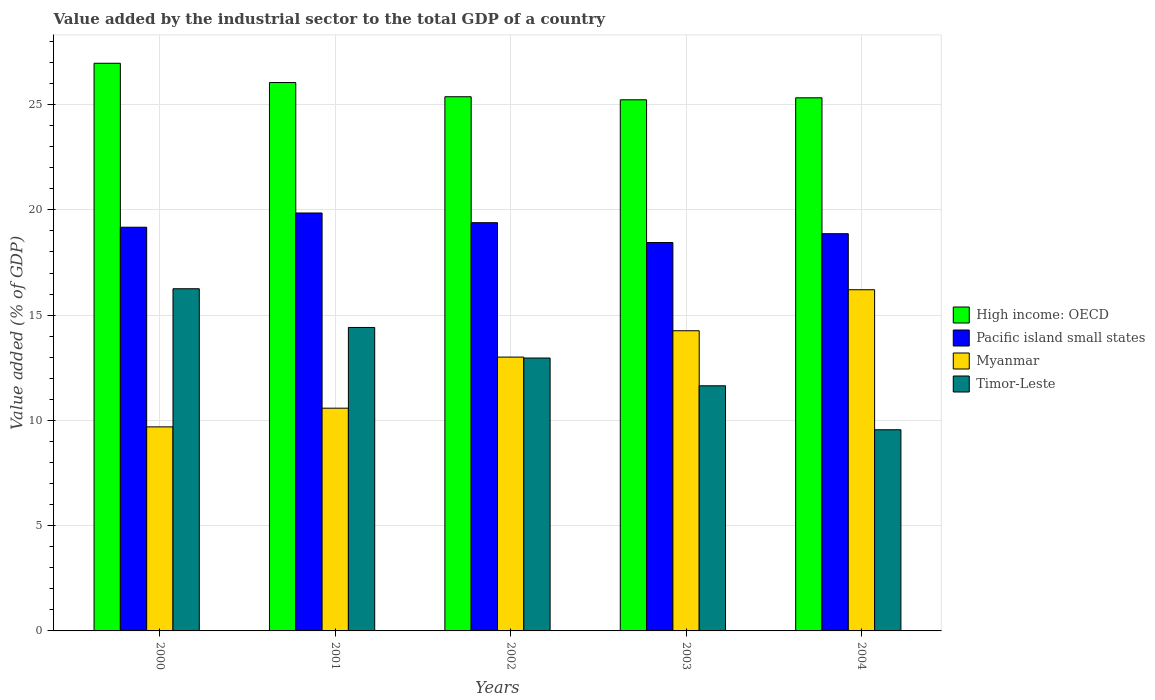How many different coloured bars are there?
Keep it short and to the point. 4. Are the number of bars on each tick of the X-axis equal?
Your answer should be compact. Yes. How many bars are there on the 5th tick from the left?
Offer a terse response. 4. In how many cases, is the number of bars for a given year not equal to the number of legend labels?
Offer a terse response. 0. What is the value added by the industrial sector to the total GDP in High income: OECD in 2004?
Make the answer very short. 25.32. Across all years, what is the maximum value added by the industrial sector to the total GDP in High income: OECD?
Give a very brief answer. 26.96. Across all years, what is the minimum value added by the industrial sector to the total GDP in Pacific island small states?
Your answer should be very brief. 18.45. In which year was the value added by the industrial sector to the total GDP in Timor-Leste minimum?
Provide a short and direct response. 2004. What is the total value added by the industrial sector to the total GDP in Pacific island small states in the graph?
Keep it short and to the point. 95.73. What is the difference between the value added by the industrial sector to the total GDP in Myanmar in 2001 and that in 2004?
Ensure brevity in your answer.  -5.63. What is the difference between the value added by the industrial sector to the total GDP in Timor-Leste in 2000 and the value added by the industrial sector to the total GDP in High income: OECD in 2001?
Your answer should be compact. -9.79. What is the average value added by the industrial sector to the total GDP in Pacific island small states per year?
Your answer should be very brief. 19.15. In the year 2000, what is the difference between the value added by the industrial sector to the total GDP in Pacific island small states and value added by the industrial sector to the total GDP in Timor-Leste?
Keep it short and to the point. 2.92. In how many years, is the value added by the industrial sector to the total GDP in Myanmar greater than 6 %?
Provide a succinct answer. 5. What is the ratio of the value added by the industrial sector to the total GDP in High income: OECD in 2000 to that in 2002?
Provide a succinct answer. 1.06. Is the value added by the industrial sector to the total GDP in High income: OECD in 2001 less than that in 2002?
Your response must be concise. No. Is the difference between the value added by the industrial sector to the total GDP in Pacific island small states in 2001 and 2003 greater than the difference between the value added by the industrial sector to the total GDP in Timor-Leste in 2001 and 2003?
Your response must be concise. No. What is the difference between the highest and the second highest value added by the industrial sector to the total GDP in Myanmar?
Your answer should be compact. 1.95. What is the difference between the highest and the lowest value added by the industrial sector to the total GDP in Myanmar?
Provide a succinct answer. 6.51. In how many years, is the value added by the industrial sector to the total GDP in High income: OECD greater than the average value added by the industrial sector to the total GDP in High income: OECD taken over all years?
Provide a succinct answer. 2. Is it the case that in every year, the sum of the value added by the industrial sector to the total GDP in Myanmar and value added by the industrial sector to the total GDP in Pacific island small states is greater than the sum of value added by the industrial sector to the total GDP in Timor-Leste and value added by the industrial sector to the total GDP in High income: OECD?
Your answer should be very brief. Yes. What does the 1st bar from the left in 2002 represents?
Offer a very short reply. High income: OECD. What does the 3rd bar from the right in 2004 represents?
Offer a very short reply. Pacific island small states. Is it the case that in every year, the sum of the value added by the industrial sector to the total GDP in Pacific island small states and value added by the industrial sector to the total GDP in High income: OECD is greater than the value added by the industrial sector to the total GDP in Timor-Leste?
Provide a short and direct response. Yes. How many bars are there?
Your response must be concise. 20. What is the difference between two consecutive major ticks on the Y-axis?
Ensure brevity in your answer.  5. Where does the legend appear in the graph?
Ensure brevity in your answer.  Center right. How are the legend labels stacked?
Your response must be concise. Vertical. What is the title of the graph?
Provide a short and direct response. Value added by the industrial sector to the total GDP of a country. What is the label or title of the Y-axis?
Your response must be concise. Value added (% of GDP). What is the Value added (% of GDP) of High income: OECD in 2000?
Your response must be concise. 26.96. What is the Value added (% of GDP) in Pacific island small states in 2000?
Your answer should be very brief. 19.18. What is the Value added (% of GDP) of Myanmar in 2000?
Your response must be concise. 9.69. What is the Value added (% of GDP) in Timor-Leste in 2000?
Give a very brief answer. 16.25. What is the Value added (% of GDP) in High income: OECD in 2001?
Give a very brief answer. 26.05. What is the Value added (% of GDP) of Pacific island small states in 2001?
Make the answer very short. 19.85. What is the Value added (% of GDP) of Myanmar in 2001?
Keep it short and to the point. 10.58. What is the Value added (% of GDP) of Timor-Leste in 2001?
Your response must be concise. 14.41. What is the Value added (% of GDP) in High income: OECD in 2002?
Make the answer very short. 25.37. What is the Value added (% of GDP) of Pacific island small states in 2002?
Offer a terse response. 19.39. What is the Value added (% of GDP) in Myanmar in 2002?
Offer a terse response. 13.01. What is the Value added (% of GDP) in Timor-Leste in 2002?
Keep it short and to the point. 12.96. What is the Value added (% of GDP) in High income: OECD in 2003?
Keep it short and to the point. 25.23. What is the Value added (% of GDP) of Pacific island small states in 2003?
Offer a very short reply. 18.45. What is the Value added (% of GDP) of Myanmar in 2003?
Keep it short and to the point. 14.26. What is the Value added (% of GDP) in Timor-Leste in 2003?
Your answer should be compact. 11.64. What is the Value added (% of GDP) in High income: OECD in 2004?
Your answer should be very brief. 25.32. What is the Value added (% of GDP) of Pacific island small states in 2004?
Your answer should be very brief. 18.87. What is the Value added (% of GDP) of Myanmar in 2004?
Make the answer very short. 16.21. What is the Value added (% of GDP) of Timor-Leste in 2004?
Make the answer very short. 9.56. Across all years, what is the maximum Value added (% of GDP) in High income: OECD?
Provide a short and direct response. 26.96. Across all years, what is the maximum Value added (% of GDP) in Pacific island small states?
Your answer should be very brief. 19.85. Across all years, what is the maximum Value added (% of GDP) of Myanmar?
Your answer should be very brief. 16.21. Across all years, what is the maximum Value added (% of GDP) of Timor-Leste?
Provide a short and direct response. 16.25. Across all years, what is the minimum Value added (% of GDP) of High income: OECD?
Your answer should be very brief. 25.23. Across all years, what is the minimum Value added (% of GDP) of Pacific island small states?
Make the answer very short. 18.45. Across all years, what is the minimum Value added (% of GDP) in Myanmar?
Give a very brief answer. 9.69. Across all years, what is the minimum Value added (% of GDP) in Timor-Leste?
Keep it short and to the point. 9.56. What is the total Value added (% of GDP) of High income: OECD in the graph?
Your response must be concise. 128.94. What is the total Value added (% of GDP) in Pacific island small states in the graph?
Keep it short and to the point. 95.73. What is the total Value added (% of GDP) of Myanmar in the graph?
Your answer should be compact. 63.74. What is the total Value added (% of GDP) in Timor-Leste in the graph?
Keep it short and to the point. 64.83. What is the difference between the Value added (% of GDP) in High income: OECD in 2000 and that in 2001?
Your response must be concise. 0.92. What is the difference between the Value added (% of GDP) in Pacific island small states in 2000 and that in 2001?
Offer a very short reply. -0.68. What is the difference between the Value added (% of GDP) of Myanmar in 2000 and that in 2001?
Provide a succinct answer. -0.89. What is the difference between the Value added (% of GDP) of Timor-Leste in 2000 and that in 2001?
Make the answer very short. 1.84. What is the difference between the Value added (% of GDP) in High income: OECD in 2000 and that in 2002?
Your answer should be compact. 1.59. What is the difference between the Value added (% of GDP) of Pacific island small states in 2000 and that in 2002?
Make the answer very short. -0.22. What is the difference between the Value added (% of GDP) in Myanmar in 2000 and that in 2002?
Provide a succinct answer. -3.31. What is the difference between the Value added (% of GDP) of Timor-Leste in 2000 and that in 2002?
Provide a short and direct response. 3.29. What is the difference between the Value added (% of GDP) in High income: OECD in 2000 and that in 2003?
Offer a terse response. 1.73. What is the difference between the Value added (% of GDP) of Pacific island small states in 2000 and that in 2003?
Ensure brevity in your answer.  0.73. What is the difference between the Value added (% of GDP) in Myanmar in 2000 and that in 2003?
Your response must be concise. -4.57. What is the difference between the Value added (% of GDP) of Timor-Leste in 2000 and that in 2003?
Your answer should be very brief. 4.61. What is the difference between the Value added (% of GDP) in High income: OECD in 2000 and that in 2004?
Ensure brevity in your answer.  1.64. What is the difference between the Value added (% of GDP) of Pacific island small states in 2000 and that in 2004?
Offer a terse response. 0.31. What is the difference between the Value added (% of GDP) in Myanmar in 2000 and that in 2004?
Offer a very short reply. -6.51. What is the difference between the Value added (% of GDP) of Timor-Leste in 2000 and that in 2004?
Your answer should be very brief. 6.7. What is the difference between the Value added (% of GDP) of High income: OECD in 2001 and that in 2002?
Your answer should be very brief. 0.67. What is the difference between the Value added (% of GDP) of Pacific island small states in 2001 and that in 2002?
Your answer should be compact. 0.46. What is the difference between the Value added (% of GDP) in Myanmar in 2001 and that in 2002?
Offer a terse response. -2.43. What is the difference between the Value added (% of GDP) in Timor-Leste in 2001 and that in 2002?
Provide a short and direct response. 1.45. What is the difference between the Value added (% of GDP) of High income: OECD in 2001 and that in 2003?
Keep it short and to the point. 0.82. What is the difference between the Value added (% of GDP) of Pacific island small states in 2001 and that in 2003?
Offer a terse response. 1.4. What is the difference between the Value added (% of GDP) of Myanmar in 2001 and that in 2003?
Ensure brevity in your answer.  -3.68. What is the difference between the Value added (% of GDP) of Timor-Leste in 2001 and that in 2003?
Give a very brief answer. 2.77. What is the difference between the Value added (% of GDP) of High income: OECD in 2001 and that in 2004?
Provide a succinct answer. 0.73. What is the difference between the Value added (% of GDP) of Pacific island small states in 2001 and that in 2004?
Your response must be concise. 0.98. What is the difference between the Value added (% of GDP) of Myanmar in 2001 and that in 2004?
Provide a short and direct response. -5.63. What is the difference between the Value added (% of GDP) of Timor-Leste in 2001 and that in 2004?
Keep it short and to the point. 4.86. What is the difference between the Value added (% of GDP) in High income: OECD in 2002 and that in 2003?
Give a very brief answer. 0.14. What is the difference between the Value added (% of GDP) in Pacific island small states in 2002 and that in 2003?
Offer a terse response. 0.94. What is the difference between the Value added (% of GDP) of Myanmar in 2002 and that in 2003?
Keep it short and to the point. -1.25. What is the difference between the Value added (% of GDP) in Timor-Leste in 2002 and that in 2003?
Offer a very short reply. 1.32. What is the difference between the Value added (% of GDP) in High income: OECD in 2002 and that in 2004?
Your response must be concise. 0.05. What is the difference between the Value added (% of GDP) of Pacific island small states in 2002 and that in 2004?
Ensure brevity in your answer.  0.52. What is the difference between the Value added (% of GDP) of Myanmar in 2002 and that in 2004?
Offer a terse response. -3.2. What is the difference between the Value added (% of GDP) of Timor-Leste in 2002 and that in 2004?
Keep it short and to the point. 3.41. What is the difference between the Value added (% of GDP) in High income: OECD in 2003 and that in 2004?
Ensure brevity in your answer.  -0.09. What is the difference between the Value added (% of GDP) of Pacific island small states in 2003 and that in 2004?
Your response must be concise. -0.42. What is the difference between the Value added (% of GDP) in Myanmar in 2003 and that in 2004?
Ensure brevity in your answer.  -1.95. What is the difference between the Value added (% of GDP) of Timor-Leste in 2003 and that in 2004?
Ensure brevity in your answer.  2.09. What is the difference between the Value added (% of GDP) in High income: OECD in 2000 and the Value added (% of GDP) in Pacific island small states in 2001?
Your answer should be compact. 7.11. What is the difference between the Value added (% of GDP) in High income: OECD in 2000 and the Value added (% of GDP) in Myanmar in 2001?
Offer a very short reply. 16.38. What is the difference between the Value added (% of GDP) of High income: OECD in 2000 and the Value added (% of GDP) of Timor-Leste in 2001?
Give a very brief answer. 12.55. What is the difference between the Value added (% of GDP) of Pacific island small states in 2000 and the Value added (% of GDP) of Myanmar in 2001?
Make the answer very short. 8.6. What is the difference between the Value added (% of GDP) of Pacific island small states in 2000 and the Value added (% of GDP) of Timor-Leste in 2001?
Give a very brief answer. 4.76. What is the difference between the Value added (% of GDP) of Myanmar in 2000 and the Value added (% of GDP) of Timor-Leste in 2001?
Offer a terse response. -4.72. What is the difference between the Value added (% of GDP) in High income: OECD in 2000 and the Value added (% of GDP) in Pacific island small states in 2002?
Provide a short and direct response. 7.57. What is the difference between the Value added (% of GDP) in High income: OECD in 2000 and the Value added (% of GDP) in Myanmar in 2002?
Provide a short and direct response. 13.96. What is the difference between the Value added (% of GDP) in High income: OECD in 2000 and the Value added (% of GDP) in Timor-Leste in 2002?
Ensure brevity in your answer.  14. What is the difference between the Value added (% of GDP) in Pacific island small states in 2000 and the Value added (% of GDP) in Myanmar in 2002?
Make the answer very short. 6.17. What is the difference between the Value added (% of GDP) in Pacific island small states in 2000 and the Value added (% of GDP) in Timor-Leste in 2002?
Make the answer very short. 6.21. What is the difference between the Value added (% of GDP) in Myanmar in 2000 and the Value added (% of GDP) in Timor-Leste in 2002?
Keep it short and to the point. -3.27. What is the difference between the Value added (% of GDP) of High income: OECD in 2000 and the Value added (% of GDP) of Pacific island small states in 2003?
Your answer should be compact. 8.52. What is the difference between the Value added (% of GDP) of High income: OECD in 2000 and the Value added (% of GDP) of Myanmar in 2003?
Ensure brevity in your answer.  12.71. What is the difference between the Value added (% of GDP) of High income: OECD in 2000 and the Value added (% of GDP) of Timor-Leste in 2003?
Provide a succinct answer. 15.32. What is the difference between the Value added (% of GDP) in Pacific island small states in 2000 and the Value added (% of GDP) in Myanmar in 2003?
Make the answer very short. 4.92. What is the difference between the Value added (% of GDP) of Pacific island small states in 2000 and the Value added (% of GDP) of Timor-Leste in 2003?
Make the answer very short. 7.53. What is the difference between the Value added (% of GDP) of Myanmar in 2000 and the Value added (% of GDP) of Timor-Leste in 2003?
Your answer should be compact. -1.95. What is the difference between the Value added (% of GDP) in High income: OECD in 2000 and the Value added (% of GDP) in Pacific island small states in 2004?
Make the answer very short. 8.1. What is the difference between the Value added (% of GDP) in High income: OECD in 2000 and the Value added (% of GDP) in Myanmar in 2004?
Give a very brief answer. 10.76. What is the difference between the Value added (% of GDP) in High income: OECD in 2000 and the Value added (% of GDP) in Timor-Leste in 2004?
Offer a very short reply. 17.41. What is the difference between the Value added (% of GDP) in Pacific island small states in 2000 and the Value added (% of GDP) in Myanmar in 2004?
Give a very brief answer. 2.97. What is the difference between the Value added (% of GDP) in Pacific island small states in 2000 and the Value added (% of GDP) in Timor-Leste in 2004?
Your answer should be very brief. 9.62. What is the difference between the Value added (% of GDP) of Myanmar in 2000 and the Value added (% of GDP) of Timor-Leste in 2004?
Your answer should be very brief. 0.14. What is the difference between the Value added (% of GDP) of High income: OECD in 2001 and the Value added (% of GDP) of Pacific island small states in 2002?
Your answer should be compact. 6.66. What is the difference between the Value added (% of GDP) of High income: OECD in 2001 and the Value added (% of GDP) of Myanmar in 2002?
Your response must be concise. 13.04. What is the difference between the Value added (% of GDP) of High income: OECD in 2001 and the Value added (% of GDP) of Timor-Leste in 2002?
Provide a short and direct response. 13.09. What is the difference between the Value added (% of GDP) of Pacific island small states in 2001 and the Value added (% of GDP) of Myanmar in 2002?
Your answer should be very brief. 6.84. What is the difference between the Value added (% of GDP) in Pacific island small states in 2001 and the Value added (% of GDP) in Timor-Leste in 2002?
Provide a succinct answer. 6.89. What is the difference between the Value added (% of GDP) of Myanmar in 2001 and the Value added (% of GDP) of Timor-Leste in 2002?
Make the answer very short. -2.38. What is the difference between the Value added (% of GDP) of High income: OECD in 2001 and the Value added (% of GDP) of Pacific island small states in 2003?
Keep it short and to the point. 7.6. What is the difference between the Value added (% of GDP) in High income: OECD in 2001 and the Value added (% of GDP) in Myanmar in 2003?
Offer a terse response. 11.79. What is the difference between the Value added (% of GDP) of High income: OECD in 2001 and the Value added (% of GDP) of Timor-Leste in 2003?
Provide a short and direct response. 14.4. What is the difference between the Value added (% of GDP) in Pacific island small states in 2001 and the Value added (% of GDP) in Myanmar in 2003?
Make the answer very short. 5.59. What is the difference between the Value added (% of GDP) of Pacific island small states in 2001 and the Value added (% of GDP) of Timor-Leste in 2003?
Give a very brief answer. 8.21. What is the difference between the Value added (% of GDP) of Myanmar in 2001 and the Value added (% of GDP) of Timor-Leste in 2003?
Ensure brevity in your answer.  -1.06. What is the difference between the Value added (% of GDP) of High income: OECD in 2001 and the Value added (% of GDP) of Pacific island small states in 2004?
Keep it short and to the point. 7.18. What is the difference between the Value added (% of GDP) of High income: OECD in 2001 and the Value added (% of GDP) of Myanmar in 2004?
Provide a short and direct response. 9.84. What is the difference between the Value added (% of GDP) in High income: OECD in 2001 and the Value added (% of GDP) in Timor-Leste in 2004?
Make the answer very short. 16.49. What is the difference between the Value added (% of GDP) in Pacific island small states in 2001 and the Value added (% of GDP) in Myanmar in 2004?
Offer a terse response. 3.65. What is the difference between the Value added (% of GDP) in Pacific island small states in 2001 and the Value added (% of GDP) in Timor-Leste in 2004?
Your answer should be very brief. 10.3. What is the difference between the Value added (% of GDP) in Myanmar in 2001 and the Value added (% of GDP) in Timor-Leste in 2004?
Provide a succinct answer. 1.02. What is the difference between the Value added (% of GDP) in High income: OECD in 2002 and the Value added (% of GDP) in Pacific island small states in 2003?
Make the answer very short. 6.93. What is the difference between the Value added (% of GDP) of High income: OECD in 2002 and the Value added (% of GDP) of Myanmar in 2003?
Make the answer very short. 11.12. What is the difference between the Value added (% of GDP) in High income: OECD in 2002 and the Value added (% of GDP) in Timor-Leste in 2003?
Provide a short and direct response. 13.73. What is the difference between the Value added (% of GDP) of Pacific island small states in 2002 and the Value added (% of GDP) of Myanmar in 2003?
Ensure brevity in your answer.  5.13. What is the difference between the Value added (% of GDP) of Pacific island small states in 2002 and the Value added (% of GDP) of Timor-Leste in 2003?
Your response must be concise. 7.75. What is the difference between the Value added (% of GDP) in Myanmar in 2002 and the Value added (% of GDP) in Timor-Leste in 2003?
Your answer should be compact. 1.36. What is the difference between the Value added (% of GDP) in High income: OECD in 2002 and the Value added (% of GDP) in Pacific island small states in 2004?
Give a very brief answer. 6.51. What is the difference between the Value added (% of GDP) of High income: OECD in 2002 and the Value added (% of GDP) of Myanmar in 2004?
Your answer should be very brief. 9.17. What is the difference between the Value added (% of GDP) of High income: OECD in 2002 and the Value added (% of GDP) of Timor-Leste in 2004?
Ensure brevity in your answer.  15.82. What is the difference between the Value added (% of GDP) in Pacific island small states in 2002 and the Value added (% of GDP) in Myanmar in 2004?
Offer a terse response. 3.19. What is the difference between the Value added (% of GDP) of Pacific island small states in 2002 and the Value added (% of GDP) of Timor-Leste in 2004?
Make the answer very short. 9.84. What is the difference between the Value added (% of GDP) of Myanmar in 2002 and the Value added (% of GDP) of Timor-Leste in 2004?
Your answer should be compact. 3.45. What is the difference between the Value added (% of GDP) in High income: OECD in 2003 and the Value added (% of GDP) in Pacific island small states in 2004?
Make the answer very short. 6.36. What is the difference between the Value added (% of GDP) in High income: OECD in 2003 and the Value added (% of GDP) in Myanmar in 2004?
Your answer should be very brief. 9.02. What is the difference between the Value added (% of GDP) of High income: OECD in 2003 and the Value added (% of GDP) of Timor-Leste in 2004?
Your answer should be compact. 15.67. What is the difference between the Value added (% of GDP) in Pacific island small states in 2003 and the Value added (% of GDP) in Myanmar in 2004?
Provide a short and direct response. 2.24. What is the difference between the Value added (% of GDP) of Pacific island small states in 2003 and the Value added (% of GDP) of Timor-Leste in 2004?
Your response must be concise. 8.89. What is the difference between the Value added (% of GDP) of Myanmar in 2003 and the Value added (% of GDP) of Timor-Leste in 2004?
Make the answer very short. 4.7. What is the average Value added (% of GDP) of High income: OECD per year?
Offer a terse response. 25.79. What is the average Value added (% of GDP) of Pacific island small states per year?
Your response must be concise. 19.15. What is the average Value added (% of GDP) in Myanmar per year?
Give a very brief answer. 12.75. What is the average Value added (% of GDP) in Timor-Leste per year?
Keep it short and to the point. 12.97. In the year 2000, what is the difference between the Value added (% of GDP) of High income: OECD and Value added (% of GDP) of Pacific island small states?
Make the answer very short. 7.79. In the year 2000, what is the difference between the Value added (% of GDP) of High income: OECD and Value added (% of GDP) of Myanmar?
Ensure brevity in your answer.  17.27. In the year 2000, what is the difference between the Value added (% of GDP) of High income: OECD and Value added (% of GDP) of Timor-Leste?
Keep it short and to the point. 10.71. In the year 2000, what is the difference between the Value added (% of GDP) of Pacific island small states and Value added (% of GDP) of Myanmar?
Your answer should be very brief. 9.48. In the year 2000, what is the difference between the Value added (% of GDP) in Pacific island small states and Value added (% of GDP) in Timor-Leste?
Give a very brief answer. 2.92. In the year 2000, what is the difference between the Value added (% of GDP) of Myanmar and Value added (% of GDP) of Timor-Leste?
Offer a very short reply. -6.56. In the year 2001, what is the difference between the Value added (% of GDP) in High income: OECD and Value added (% of GDP) in Pacific island small states?
Your response must be concise. 6.2. In the year 2001, what is the difference between the Value added (% of GDP) in High income: OECD and Value added (% of GDP) in Myanmar?
Make the answer very short. 15.47. In the year 2001, what is the difference between the Value added (% of GDP) in High income: OECD and Value added (% of GDP) in Timor-Leste?
Provide a short and direct response. 11.63. In the year 2001, what is the difference between the Value added (% of GDP) of Pacific island small states and Value added (% of GDP) of Myanmar?
Your answer should be compact. 9.27. In the year 2001, what is the difference between the Value added (% of GDP) of Pacific island small states and Value added (% of GDP) of Timor-Leste?
Make the answer very short. 5.44. In the year 2001, what is the difference between the Value added (% of GDP) in Myanmar and Value added (% of GDP) in Timor-Leste?
Give a very brief answer. -3.83. In the year 2002, what is the difference between the Value added (% of GDP) in High income: OECD and Value added (% of GDP) in Pacific island small states?
Provide a short and direct response. 5.98. In the year 2002, what is the difference between the Value added (% of GDP) in High income: OECD and Value added (% of GDP) in Myanmar?
Make the answer very short. 12.37. In the year 2002, what is the difference between the Value added (% of GDP) in High income: OECD and Value added (% of GDP) in Timor-Leste?
Provide a succinct answer. 12.41. In the year 2002, what is the difference between the Value added (% of GDP) in Pacific island small states and Value added (% of GDP) in Myanmar?
Offer a terse response. 6.38. In the year 2002, what is the difference between the Value added (% of GDP) of Pacific island small states and Value added (% of GDP) of Timor-Leste?
Provide a short and direct response. 6.43. In the year 2002, what is the difference between the Value added (% of GDP) in Myanmar and Value added (% of GDP) in Timor-Leste?
Your answer should be compact. 0.04. In the year 2003, what is the difference between the Value added (% of GDP) of High income: OECD and Value added (% of GDP) of Pacific island small states?
Your answer should be very brief. 6.78. In the year 2003, what is the difference between the Value added (% of GDP) in High income: OECD and Value added (% of GDP) in Myanmar?
Keep it short and to the point. 10.97. In the year 2003, what is the difference between the Value added (% of GDP) of High income: OECD and Value added (% of GDP) of Timor-Leste?
Provide a short and direct response. 13.59. In the year 2003, what is the difference between the Value added (% of GDP) in Pacific island small states and Value added (% of GDP) in Myanmar?
Your answer should be very brief. 4.19. In the year 2003, what is the difference between the Value added (% of GDP) in Pacific island small states and Value added (% of GDP) in Timor-Leste?
Make the answer very short. 6.8. In the year 2003, what is the difference between the Value added (% of GDP) of Myanmar and Value added (% of GDP) of Timor-Leste?
Keep it short and to the point. 2.61. In the year 2004, what is the difference between the Value added (% of GDP) of High income: OECD and Value added (% of GDP) of Pacific island small states?
Ensure brevity in your answer.  6.45. In the year 2004, what is the difference between the Value added (% of GDP) in High income: OECD and Value added (% of GDP) in Myanmar?
Keep it short and to the point. 9.12. In the year 2004, what is the difference between the Value added (% of GDP) of High income: OECD and Value added (% of GDP) of Timor-Leste?
Make the answer very short. 15.77. In the year 2004, what is the difference between the Value added (% of GDP) in Pacific island small states and Value added (% of GDP) in Myanmar?
Offer a very short reply. 2.66. In the year 2004, what is the difference between the Value added (% of GDP) of Pacific island small states and Value added (% of GDP) of Timor-Leste?
Offer a terse response. 9.31. In the year 2004, what is the difference between the Value added (% of GDP) in Myanmar and Value added (% of GDP) in Timor-Leste?
Give a very brief answer. 6.65. What is the ratio of the Value added (% of GDP) of High income: OECD in 2000 to that in 2001?
Give a very brief answer. 1.04. What is the ratio of the Value added (% of GDP) in Pacific island small states in 2000 to that in 2001?
Give a very brief answer. 0.97. What is the ratio of the Value added (% of GDP) in Myanmar in 2000 to that in 2001?
Make the answer very short. 0.92. What is the ratio of the Value added (% of GDP) of Timor-Leste in 2000 to that in 2001?
Keep it short and to the point. 1.13. What is the ratio of the Value added (% of GDP) of High income: OECD in 2000 to that in 2002?
Offer a terse response. 1.06. What is the ratio of the Value added (% of GDP) in Pacific island small states in 2000 to that in 2002?
Provide a short and direct response. 0.99. What is the ratio of the Value added (% of GDP) of Myanmar in 2000 to that in 2002?
Your answer should be very brief. 0.75. What is the ratio of the Value added (% of GDP) in Timor-Leste in 2000 to that in 2002?
Provide a succinct answer. 1.25. What is the ratio of the Value added (% of GDP) of High income: OECD in 2000 to that in 2003?
Give a very brief answer. 1.07. What is the ratio of the Value added (% of GDP) of Pacific island small states in 2000 to that in 2003?
Give a very brief answer. 1.04. What is the ratio of the Value added (% of GDP) of Myanmar in 2000 to that in 2003?
Provide a short and direct response. 0.68. What is the ratio of the Value added (% of GDP) of Timor-Leste in 2000 to that in 2003?
Keep it short and to the point. 1.4. What is the ratio of the Value added (% of GDP) in High income: OECD in 2000 to that in 2004?
Your response must be concise. 1.06. What is the ratio of the Value added (% of GDP) in Pacific island small states in 2000 to that in 2004?
Ensure brevity in your answer.  1.02. What is the ratio of the Value added (% of GDP) in Myanmar in 2000 to that in 2004?
Offer a very short reply. 0.6. What is the ratio of the Value added (% of GDP) in Timor-Leste in 2000 to that in 2004?
Offer a very short reply. 1.7. What is the ratio of the Value added (% of GDP) in High income: OECD in 2001 to that in 2002?
Provide a succinct answer. 1.03. What is the ratio of the Value added (% of GDP) of Pacific island small states in 2001 to that in 2002?
Provide a succinct answer. 1.02. What is the ratio of the Value added (% of GDP) in Myanmar in 2001 to that in 2002?
Offer a very short reply. 0.81. What is the ratio of the Value added (% of GDP) of Timor-Leste in 2001 to that in 2002?
Provide a short and direct response. 1.11. What is the ratio of the Value added (% of GDP) in High income: OECD in 2001 to that in 2003?
Offer a terse response. 1.03. What is the ratio of the Value added (% of GDP) of Pacific island small states in 2001 to that in 2003?
Ensure brevity in your answer.  1.08. What is the ratio of the Value added (% of GDP) in Myanmar in 2001 to that in 2003?
Your response must be concise. 0.74. What is the ratio of the Value added (% of GDP) of Timor-Leste in 2001 to that in 2003?
Keep it short and to the point. 1.24. What is the ratio of the Value added (% of GDP) in High income: OECD in 2001 to that in 2004?
Give a very brief answer. 1.03. What is the ratio of the Value added (% of GDP) in Pacific island small states in 2001 to that in 2004?
Offer a very short reply. 1.05. What is the ratio of the Value added (% of GDP) in Myanmar in 2001 to that in 2004?
Your response must be concise. 0.65. What is the ratio of the Value added (% of GDP) in Timor-Leste in 2001 to that in 2004?
Ensure brevity in your answer.  1.51. What is the ratio of the Value added (% of GDP) in High income: OECD in 2002 to that in 2003?
Offer a very short reply. 1.01. What is the ratio of the Value added (% of GDP) of Pacific island small states in 2002 to that in 2003?
Provide a short and direct response. 1.05. What is the ratio of the Value added (% of GDP) of Myanmar in 2002 to that in 2003?
Offer a terse response. 0.91. What is the ratio of the Value added (% of GDP) of Timor-Leste in 2002 to that in 2003?
Your answer should be very brief. 1.11. What is the ratio of the Value added (% of GDP) of High income: OECD in 2002 to that in 2004?
Make the answer very short. 1. What is the ratio of the Value added (% of GDP) of Pacific island small states in 2002 to that in 2004?
Your response must be concise. 1.03. What is the ratio of the Value added (% of GDP) of Myanmar in 2002 to that in 2004?
Your answer should be very brief. 0.8. What is the ratio of the Value added (% of GDP) in Timor-Leste in 2002 to that in 2004?
Offer a very short reply. 1.36. What is the ratio of the Value added (% of GDP) of Pacific island small states in 2003 to that in 2004?
Make the answer very short. 0.98. What is the ratio of the Value added (% of GDP) of Myanmar in 2003 to that in 2004?
Make the answer very short. 0.88. What is the ratio of the Value added (% of GDP) of Timor-Leste in 2003 to that in 2004?
Make the answer very short. 1.22. What is the difference between the highest and the second highest Value added (% of GDP) of High income: OECD?
Offer a very short reply. 0.92. What is the difference between the highest and the second highest Value added (% of GDP) in Pacific island small states?
Make the answer very short. 0.46. What is the difference between the highest and the second highest Value added (% of GDP) of Myanmar?
Your answer should be very brief. 1.95. What is the difference between the highest and the second highest Value added (% of GDP) of Timor-Leste?
Your answer should be compact. 1.84. What is the difference between the highest and the lowest Value added (% of GDP) of High income: OECD?
Offer a very short reply. 1.73. What is the difference between the highest and the lowest Value added (% of GDP) of Pacific island small states?
Your answer should be compact. 1.4. What is the difference between the highest and the lowest Value added (% of GDP) in Myanmar?
Offer a terse response. 6.51. What is the difference between the highest and the lowest Value added (% of GDP) of Timor-Leste?
Offer a terse response. 6.7. 